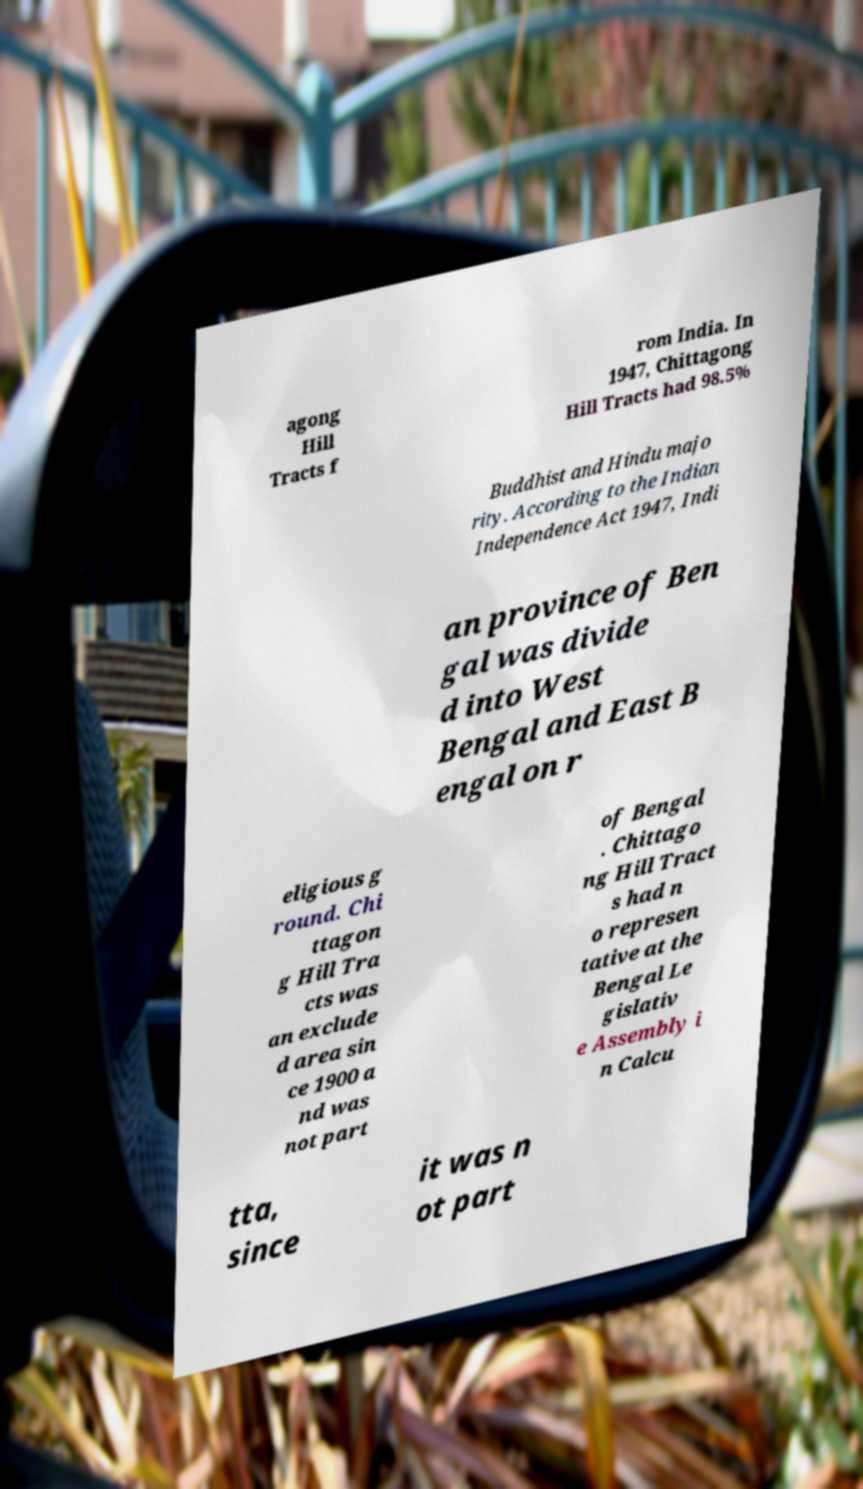Please read and relay the text visible in this image. What does it say? agong Hill Tracts f rom India. In 1947, Chittagong Hill Tracts had 98.5% Buddhist and Hindu majo rity. According to the Indian Independence Act 1947, Indi an province of Ben gal was divide d into West Bengal and East B engal on r eligious g round. Chi ttagon g Hill Tra cts was an exclude d area sin ce 1900 a nd was not part of Bengal . Chittago ng Hill Tract s had n o represen tative at the Bengal Le gislativ e Assembly i n Calcu tta, since it was n ot part 